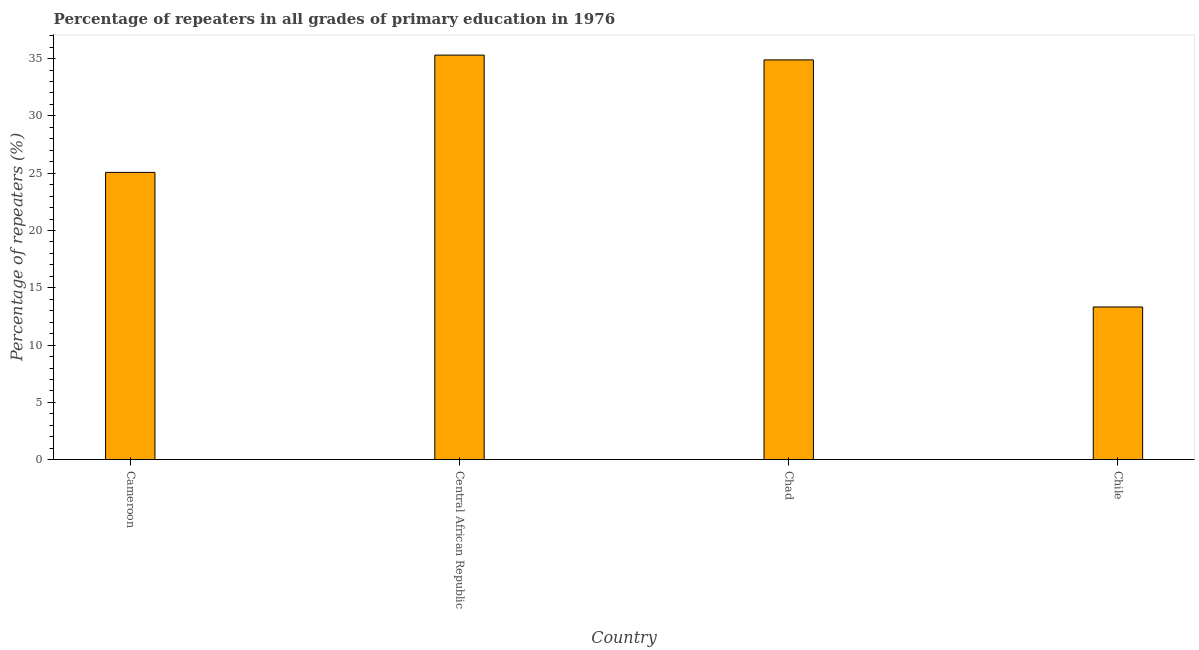What is the title of the graph?
Make the answer very short. Percentage of repeaters in all grades of primary education in 1976. What is the label or title of the X-axis?
Provide a short and direct response. Country. What is the label or title of the Y-axis?
Provide a succinct answer. Percentage of repeaters (%). What is the percentage of repeaters in primary education in Cameroon?
Your response must be concise. 25.07. Across all countries, what is the maximum percentage of repeaters in primary education?
Make the answer very short. 35.3. Across all countries, what is the minimum percentage of repeaters in primary education?
Your answer should be very brief. 13.33. In which country was the percentage of repeaters in primary education maximum?
Your response must be concise. Central African Republic. What is the sum of the percentage of repeaters in primary education?
Your answer should be compact. 108.58. What is the difference between the percentage of repeaters in primary education in Chad and Chile?
Your response must be concise. 21.56. What is the average percentage of repeaters in primary education per country?
Your answer should be compact. 27.15. What is the median percentage of repeaters in primary education?
Your response must be concise. 29.98. In how many countries, is the percentage of repeaters in primary education greater than 30 %?
Make the answer very short. 2. What is the ratio of the percentage of repeaters in primary education in Chad to that in Chile?
Your answer should be compact. 2.62. Is the percentage of repeaters in primary education in Cameroon less than that in Chile?
Your answer should be compact. No. What is the difference between the highest and the second highest percentage of repeaters in primary education?
Your answer should be compact. 0.42. What is the difference between the highest and the lowest percentage of repeaters in primary education?
Keep it short and to the point. 21.98. In how many countries, is the percentage of repeaters in primary education greater than the average percentage of repeaters in primary education taken over all countries?
Keep it short and to the point. 2. How many bars are there?
Offer a terse response. 4. Are all the bars in the graph horizontal?
Your answer should be compact. No. How many countries are there in the graph?
Offer a very short reply. 4. What is the difference between two consecutive major ticks on the Y-axis?
Offer a terse response. 5. Are the values on the major ticks of Y-axis written in scientific E-notation?
Give a very brief answer. No. What is the Percentage of repeaters (%) of Cameroon?
Your answer should be compact. 25.07. What is the Percentage of repeaters (%) in Central African Republic?
Keep it short and to the point. 35.3. What is the Percentage of repeaters (%) in Chad?
Make the answer very short. 34.88. What is the Percentage of repeaters (%) of Chile?
Your answer should be compact. 13.33. What is the difference between the Percentage of repeaters (%) in Cameroon and Central African Republic?
Offer a very short reply. -10.23. What is the difference between the Percentage of repeaters (%) in Cameroon and Chad?
Offer a very short reply. -9.81. What is the difference between the Percentage of repeaters (%) in Cameroon and Chile?
Provide a succinct answer. 11.74. What is the difference between the Percentage of repeaters (%) in Central African Republic and Chad?
Offer a terse response. 0.42. What is the difference between the Percentage of repeaters (%) in Central African Republic and Chile?
Ensure brevity in your answer.  21.98. What is the difference between the Percentage of repeaters (%) in Chad and Chile?
Offer a very short reply. 21.56. What is the ratio of the Percentage of repeaters (%) in Cameroon to that in Central African Republic?
Make the answer very short. 0.71. What is the ratio of the Percentage of repeaters (%) in Cameroon to that in Chad?
Give a very brief answer. 0.72. What is the ratio of the Percentage of repeaters (%) in Cameroon to that in Chile?
Ensure brevity in your answer.  1.88. What is the ratio of the Percentage of repeaters (%) in Central African Republic to that in Chile?
Your answer should be compact. 2.65. What is the ratio of the Percentage of repeaters (%) in Chad to that in Chile?
Offer a very short reply. 2.62. 